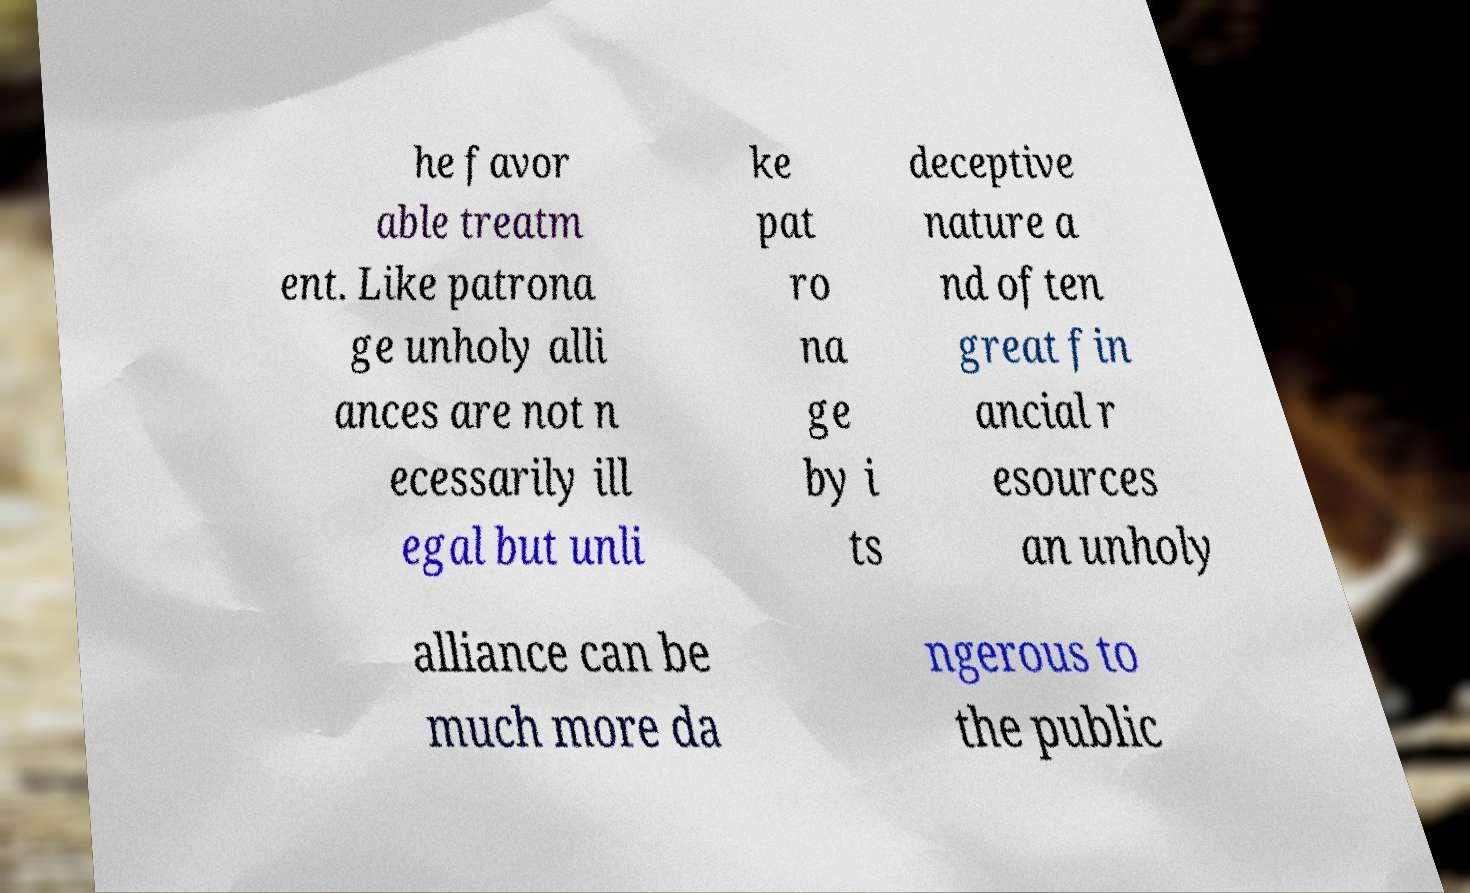Could you assist in decoding the text presented in this image and type it out clearly? he favor able treatm ent. Like patrona ge unholy alli ances are not n ecessarily ill egal but unli ke pat ro na ge by i ts deceptive nature a nd often great fin ancial r esources an unholy alliance can be much more da ngerous to the public 